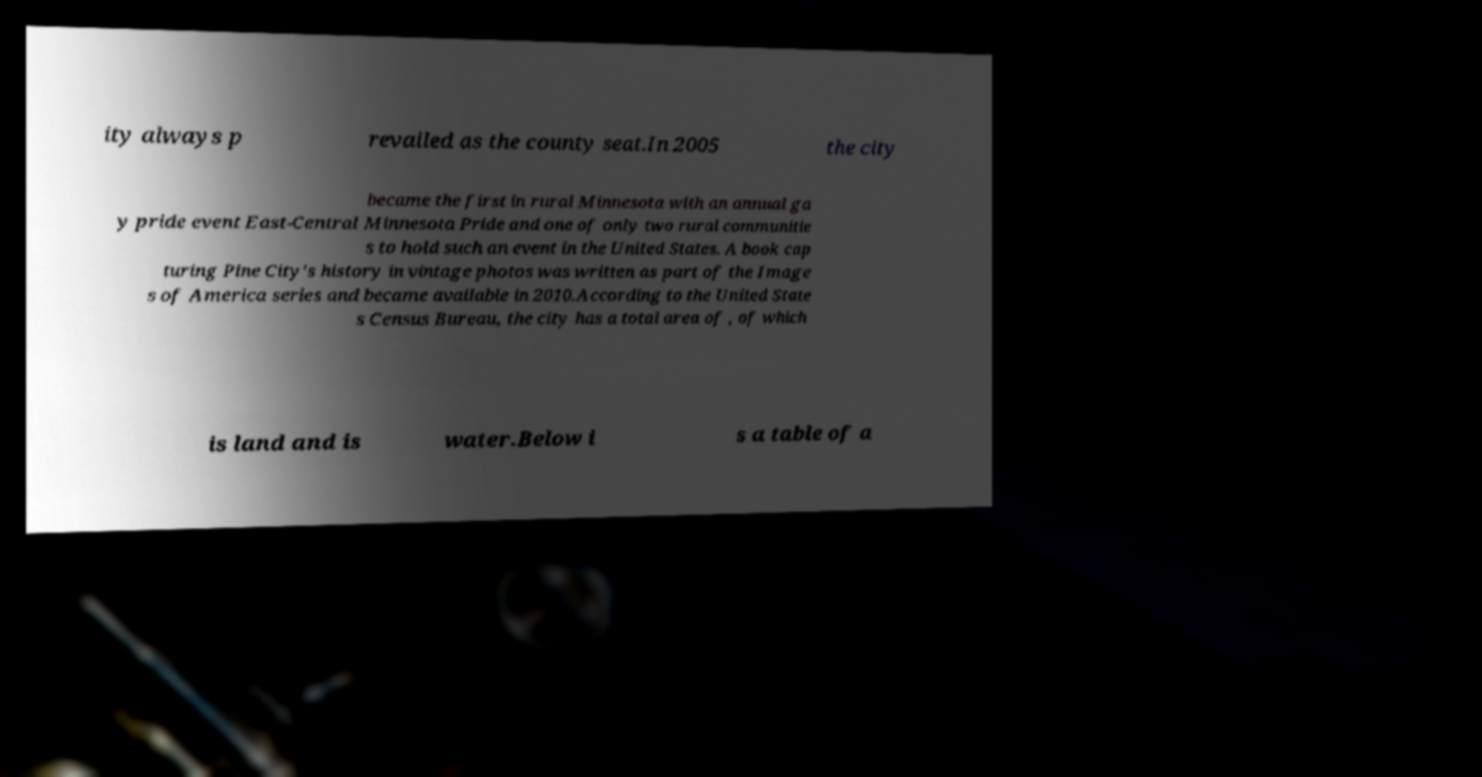Could you extract and type out the text from this image? ity always p revailed as the county seat.In 2005 the city became the first in rural Minnesota with an annual ga y pride event East-Central Minnesota Pride and one of only two rural communitie s to hold such an event in the United States. A book cap turing Pine City's history in vintage photos was written as part of the Image s of America series and became available in 2010.According to the United State s Census Bureau, the city has a total area of , of which is land and is water.Below i s a table of a 